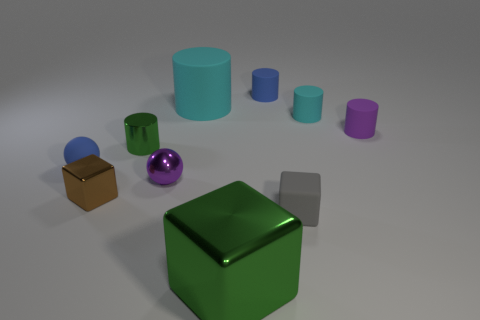Are there any other things that are the same size as the green metallic cylinder?
Your answer should be compact. Yes. Do the small gray object and the big green metallic thing have the same shape?
Your answer should be very brief. Yes. What number of tiny balls are to the right of the tiny blue ball?
Provide a short and direct response. 1. There is a cyan thing to the left of the blue thing that is to the right of the large green metal cube; what is its shape?
Provide a short and direct response. Cylinder. There is a tiny blue object that is made of the same material as the blue sphere; what shape is it?
Make the answer very short. Cylinder. There is a cyan rubber cylinder behind the tiny cyan cylinder; is its size the same as the metal cube behind the small gray object?
Keep it short and to the point. No. There is a blue matte object to the left of the tiny blue cylinder; what is its shape?
Offer a terse response. Sphere. What color is the tiny metal cylinder?
Provide a short and direct response. Green. There is a gray thing; is its size the same as the blue rubber thing to the right of the tiny blue ball?
Make the answer very short. Yes. How many rubber things are purple cylinders or green objects?
Offer a terse response. 1. 